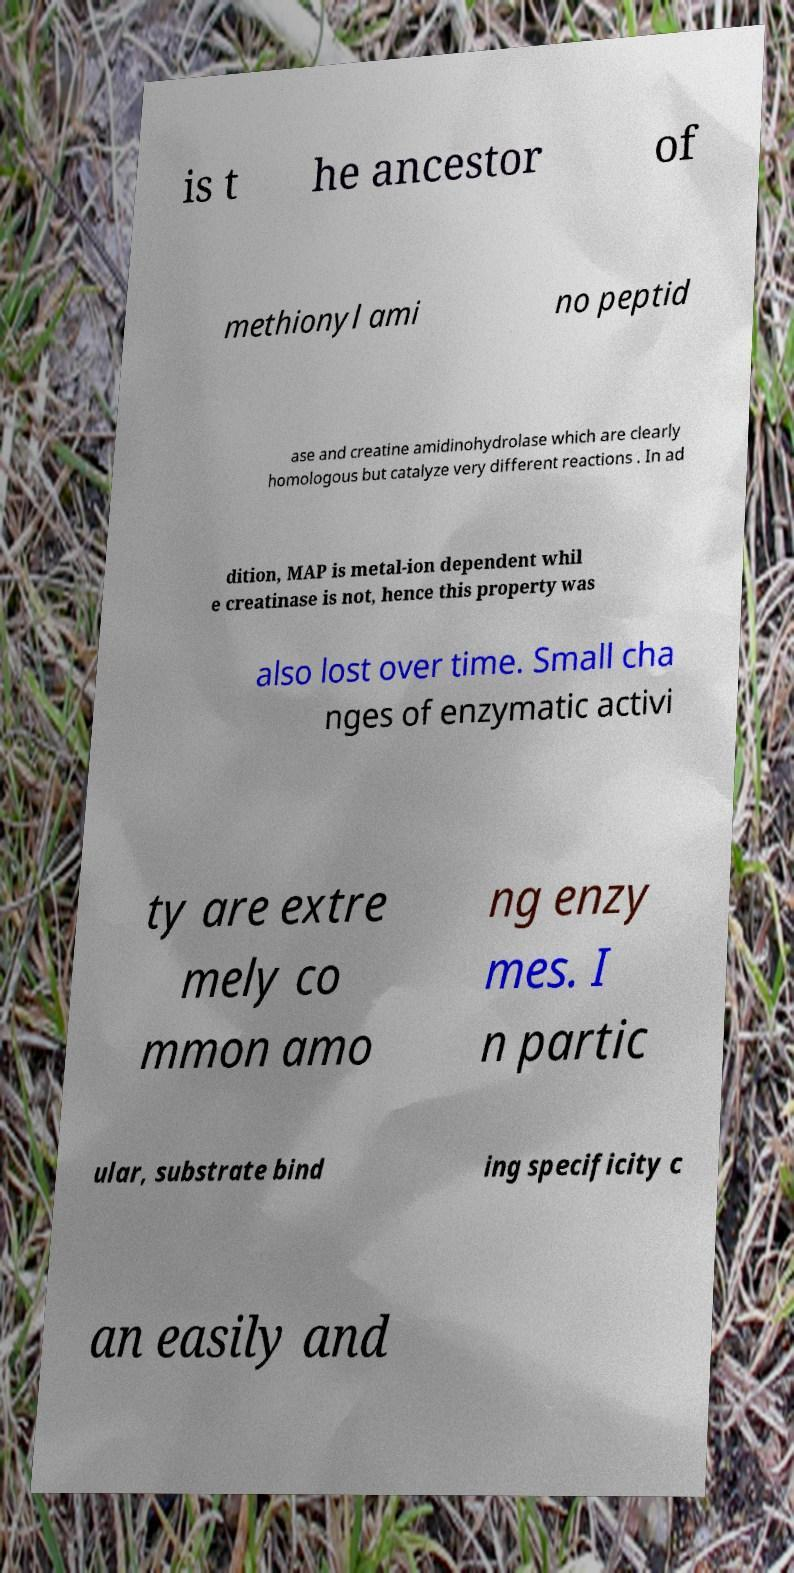Please identify and transcribe the text found in this image. is t he ancestor of methionyl ami no peptid ase and creatine amidinohydrolase which are clearly homologous but catalyze very different reactions . In ad dition, MAP is metal-ion dependent whil e creatinase is not, hence this property was also lost over time. Small cha nges of enzymatic activi ty are extre mely co mmon amo ng enzy mes. I n partic ular, substrate bind ing specificity c an easily and 